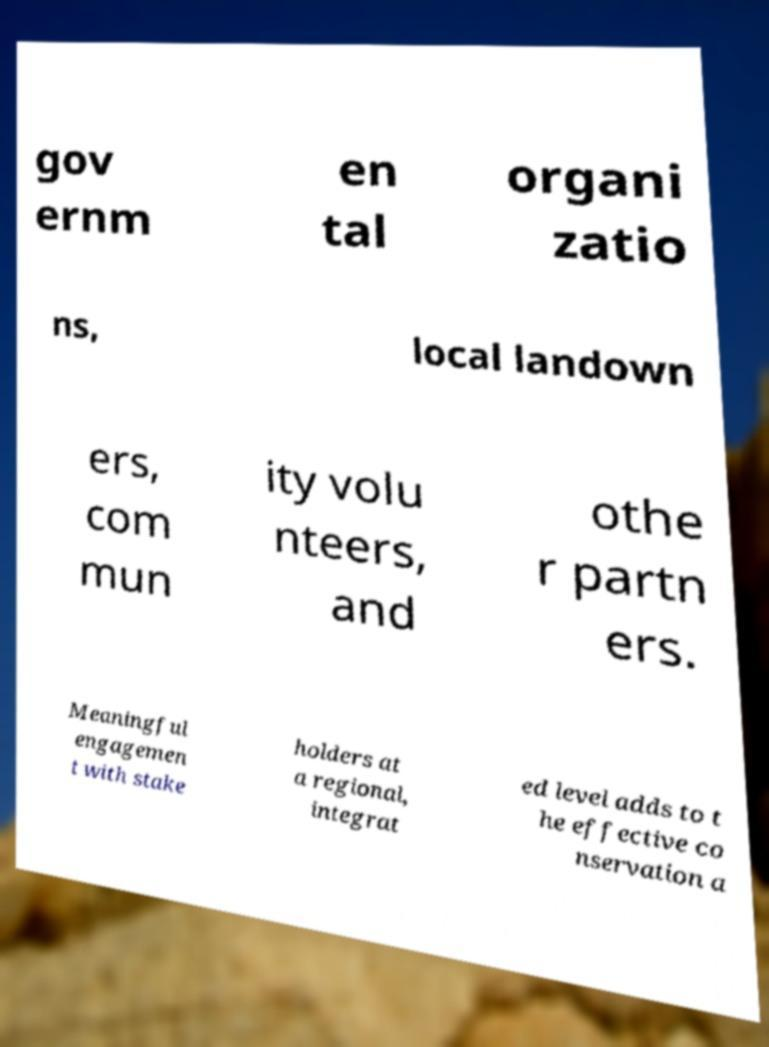Can you read and provide the text displayed in the image?This photo seems to have some interesting text. Can you extract and type it out for me? gov ernm en tal organi zatio ns, local landown ers, com mun ity volu nteers, and othe r partn ers. Meaningful engagemen t with stake holders at a regional, integrat ed level adds to t he effective co nservation a 